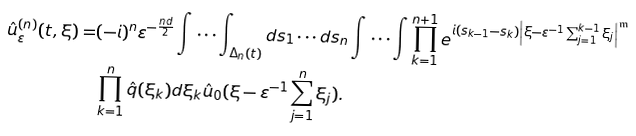Convert formula to latex. <formula><loc_0><loc_0><loc_500><loc_500>\hat { u } _ { \varepsilon } ^ { ( n ) } ( t , \xi ) = & ( - i ) ^ { n } \varepsilon ^ { - \frac { n d } { 2 } } \int \cdots \int _ { \Delta _ { n } ( t ) } d s _ { 1 } \cdots d s _ { n } \int \cdots \int \prod _ { k = 1 } ^ { n + 1 } e ^ { i ( s _ { k - 1 } - s _ { k } ) \left | \xi - \varepsilon ^ { - 1 } \sum _ { j = 1 } ^ { k - 1 } \xi _ { j } \right | ^ { \mathfrak { m } } } \\ & \prod _ { k = 1 } ^ { n } \hat { q } ( \xi _ { k } ) d \xi _ { k } \hat { u } _ { 0 } ( \xi - \varepsilon ^ { - 1 } \sum _ { j = 1 } ^ { n } \xi _ { j } ) .</formula> 